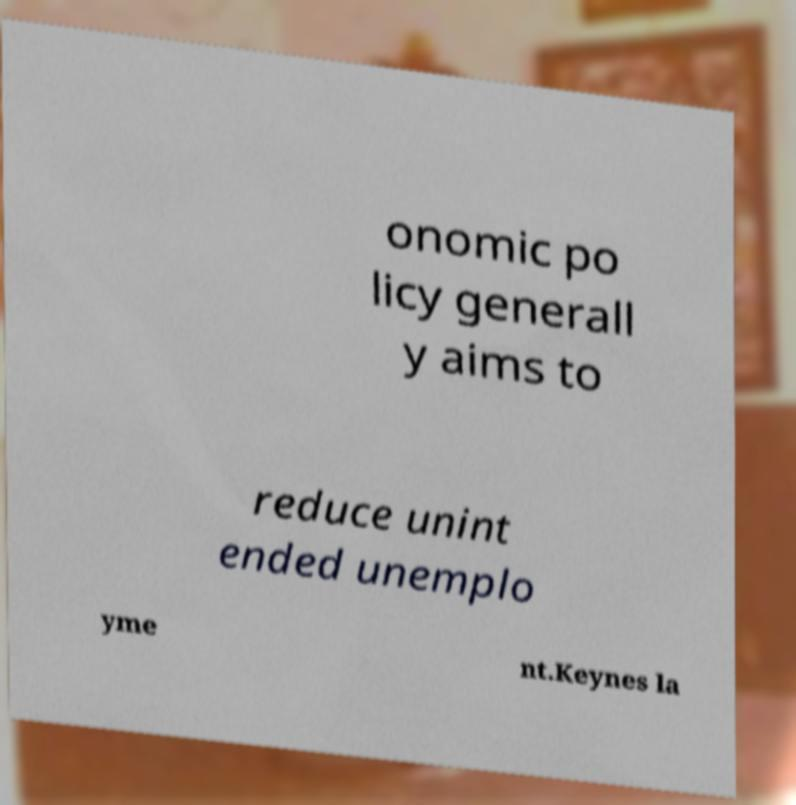Could you extract and type out the text from this image? onomic po licy generall y aims to reduce unint ended unemplo yme nt.Keynes la 